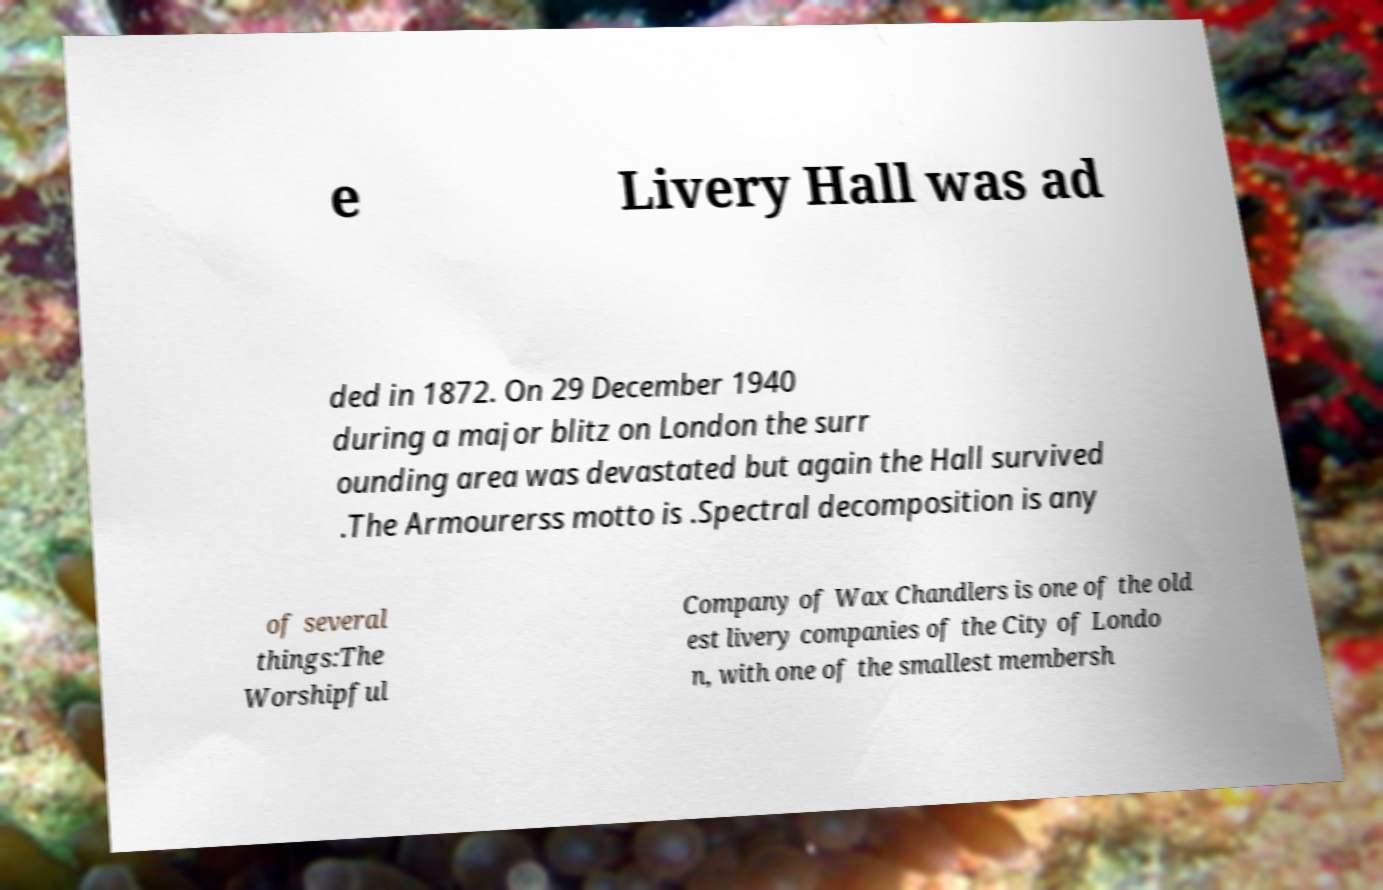I need the written content from this picture converted into text. Can you do that? e Livery Hall was ad ded in 1872. On 29 December 1940 during a major blitz on London the surr ounding area was devastated but again the Hall survived .The Armourerss motto is .Spectral decomposition is any of several things:The Worshipful Company of Wax Chandlers is one of the old est livery companies of the City of Londo n, with one of the smallest membersh 